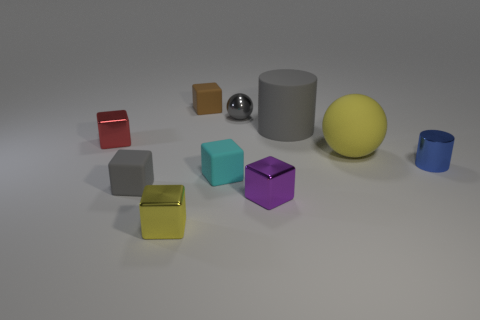Are there any tiny blue metallic objects left of the tiny red object?
Make the answer very short. No. Is the tiny cube to the left of the tiny gray matte thing made of the same material as the yellow thing that is in front of the tiny blue object?
Provide a succinct answer. Yes. Is the number of gray metal balls that are in front of the tiny cyan block less than the number of matte objects?
Make the answer very short. Yes. What is the color of the tiny matte block behind the large gray cylinder?
Give a very brief answer. Brown. What is the yellow thing left of the matte cube behind the shiny cylinder made of?
Offer a terse response. Metal. Is there a brown matte object of the same size as the red thing?
Ensure brevity in your answer.  Yes. What number of things are either objects on the left side of the large yellow rubber thing or things that are behind the big yellow rubber thing?
Ensure brevity in your answer.  8. There is a yellow thing right of the brown rubber cube; does it have the same size as the cube behind the small red shiny object?
Make the answer very short. No. Is there a shiny block that is right of the cylinder behind the small metallic cylinder?
Provide a short and direct response. No. There is a large yellow rubber object; what number of tiny blue things are in front of it?
Make the answer very short. 1. 